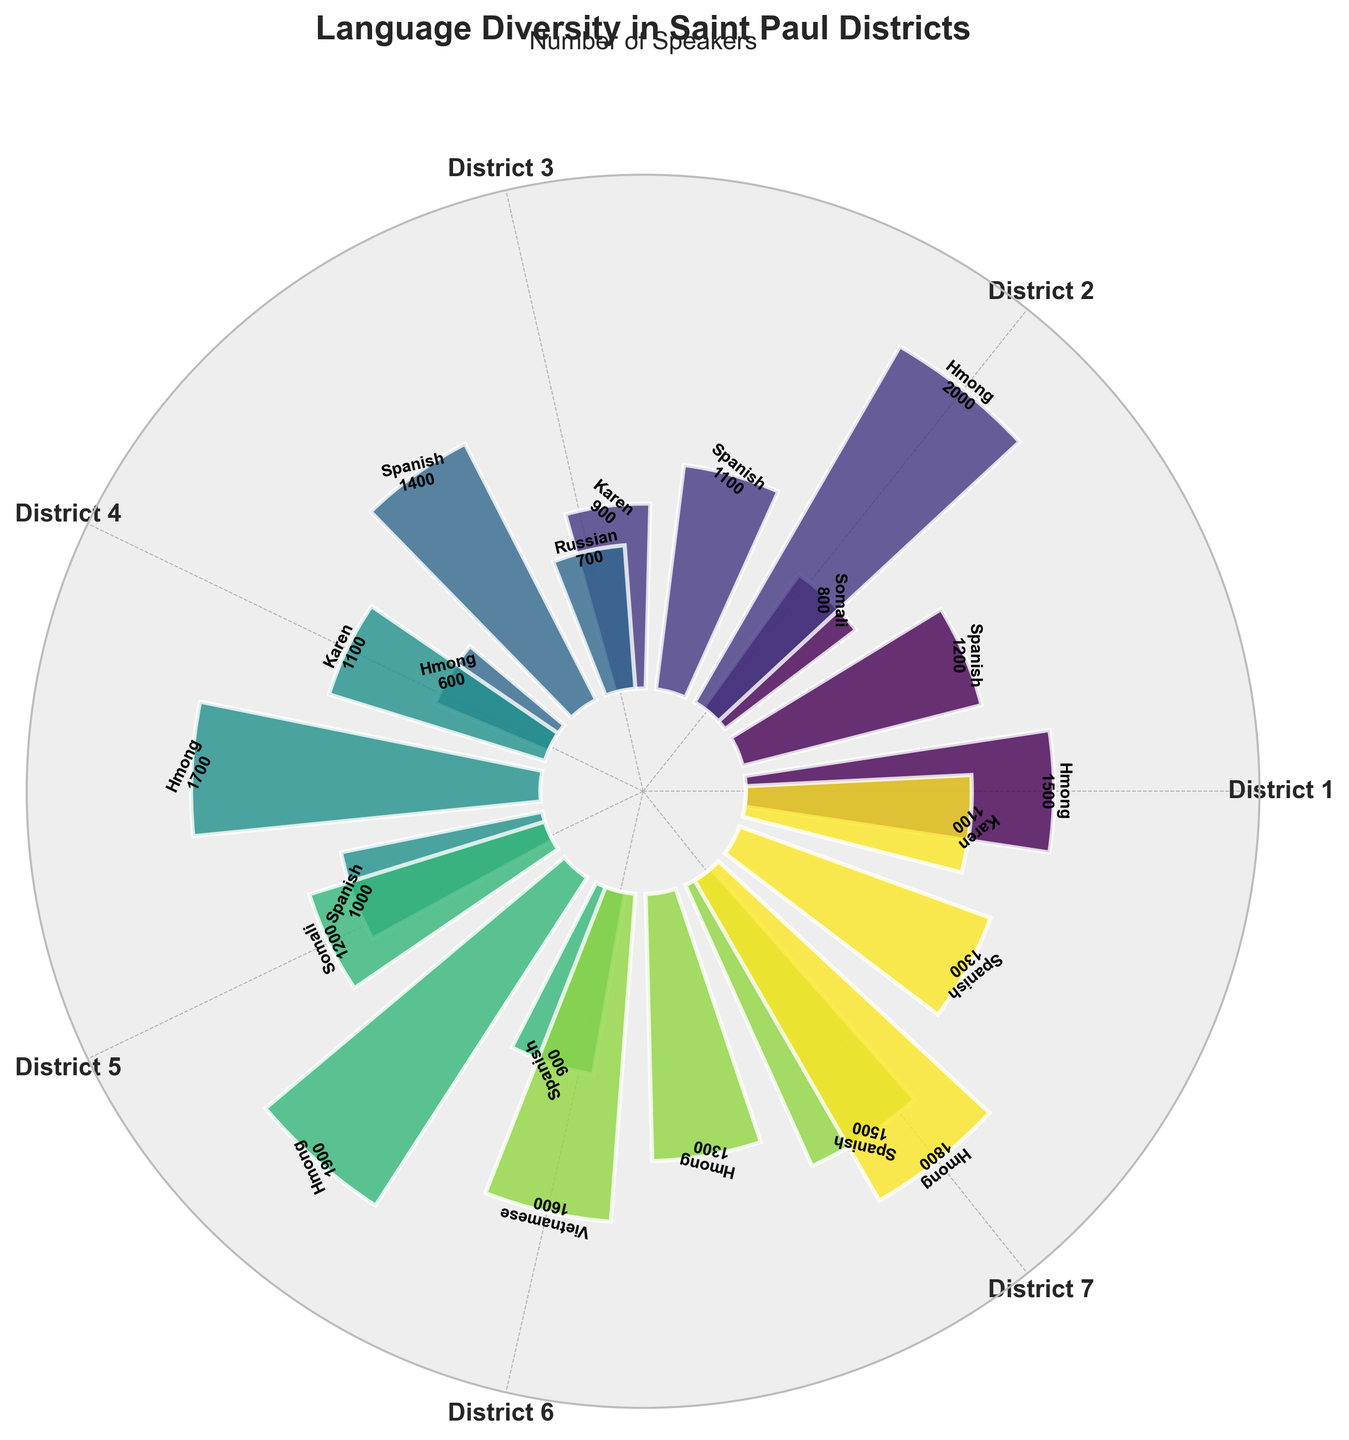What is the title of the chart? The title is positioned at the top of the chart. By looking at it, we can read it directly.
Answer: Language Diversity in Saint Paul Districts Which language has the highest number of speakers in District 1? Identify District 1 sections, then compare heights of the bars. The tallest bar is labeled "Hmong: 1500".
Answer: Hmong Which district has the fewest Spanish speakers? Locate the bars labeled "Spanish" in each district. Compare the heights. District 5's Spanish bar is the shortest with 900 speakers.
Answer: District 5 What is the total number of Hmong speakers across all districts? Sum the Hmong speaker numbers from all districts: 1500 + 2000 + 600 + 1700 + 1900 + 1300 + 1800 = 10800.
Answer: 10800 In which district is the number of Karen speakers equal to 1100? Find the "Karen" label with the corresponding height of 1100. It appears in Districts 4 and 7.
Answer: Districts 4 and 7 Which district has the most diverse language representation in terms of different languages? Count the number of distinct language bars in each district. All districts except District 3 have three distinct languages, while District 3 has only three, making it the least diverse.
Answer: All districts except District 3 What is the sum of the number of Spanish speakers in Districts 2 and 6? Add Spanish speakers in District 2 and District 6: 1100 + 1500 = 2600.
Answer: 2600 Which district has the least number of Hmong speakers? Locate the bars labeled "Hmong" and compare their heights across districts. District 3 has the fewest with 600 speakers.
Answer: District 3 Which language has the highest number of speakers in all districts combined? Sum the speakers of each language across all districts and compare the sums. Hmong has the highest cumulative number of speakers.
Answer: Hmong Which languages are spoken in both District 1 and District 5? Identify the overlapping language labels between the two districts. Common languages are Hmong and Somali.
Answer: Hmong and Somali 